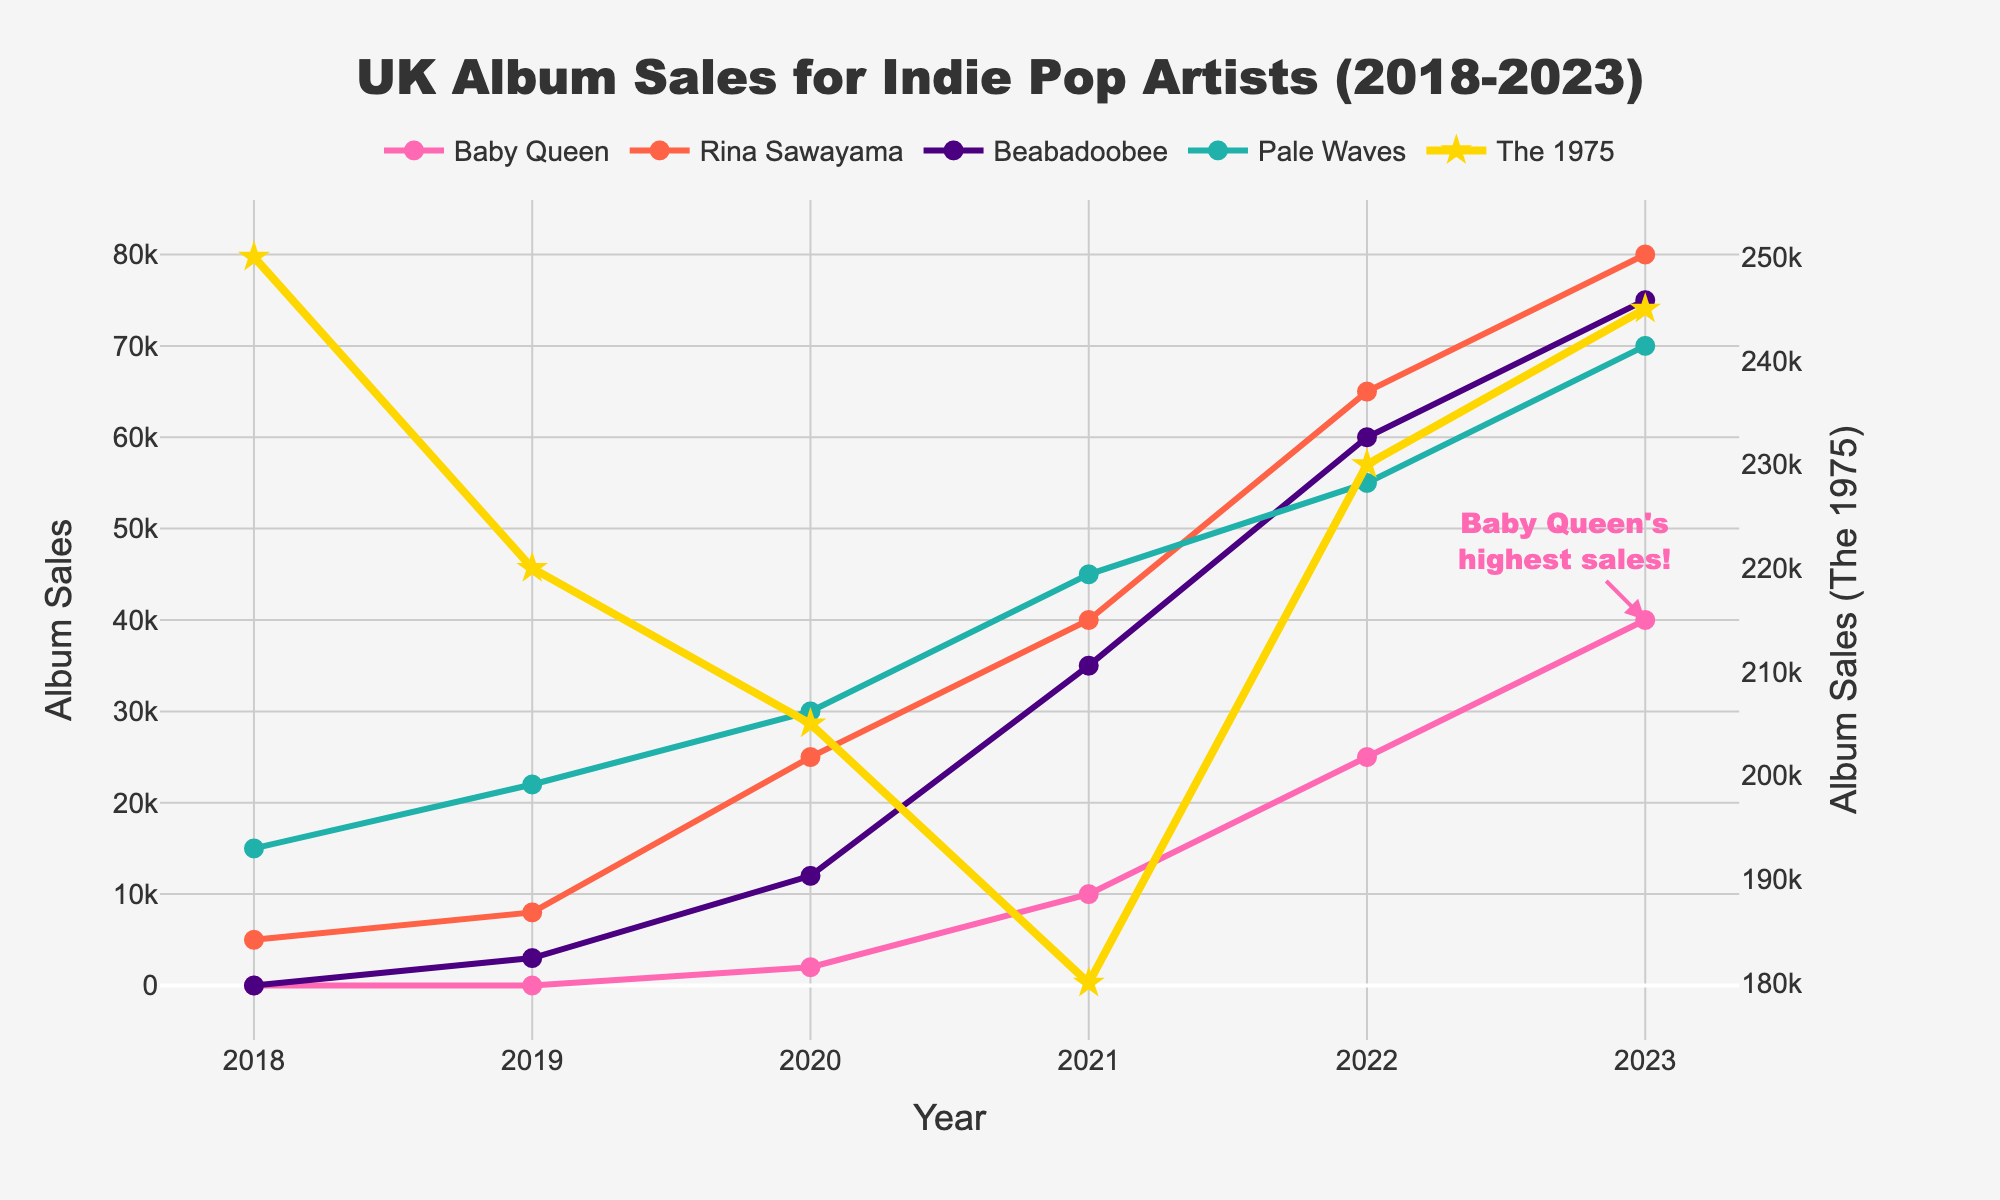What year did Baby Queen first appear in the album sales chart? Baby Queen first appears with sales greater than zero in the year 2020.
Answer: 2020 What is the difference in album sales between Rina Sawayama and Beabadoobee in 2021? In 2021, Rina Sawayama sold 40,000 albums, and Beabadoobee sold 35,000. The difference is 40,000 - 35,000 = 5,000.
Answer: 5,000 Which year saw the highest album sales for Baby Queen? By examining the trend of Baby Queen's sales, the highest value occurs in 2023.
Answer: 2023 How do the album sales of Pale Waves compare between 2018 and 2023? Pale Waves sold 15,000 albums in 2018 and 70,000 albums in 2023. This shows an increase of 70,000 - 15,000 = 55,000.
Answer: Increased by 55,000 What colors are used to represent Baby Queen and Beabadoobee in the plot? The figure represents Baby Queen with a pink line and Beabadoobee with an indigo line.
Answer: Pink and Indigo What is the total album sales for The 1975 over the 6-year period? The album sales are 250,000 (2018) + 220,000 (2019) + 205,000 (2020) + 180,000 (2021) + 230,000 (2022) + 245,000 (2023) = 1,330,000.
Answer: 1,330,000 Which year showed the largest increase in sales for Rina Sawayama compared to the previous year? Rina Sawayama's sales saw the largest increase from 2019 to 2020, going from 8,000 to 25,000, which is an increase of 17,000.
Answer: 2020 What is the average album sales in 2020 for Baby Queen, Rina Sawayama, and Beabadoobee? The sales in 2020 are 2,000 (Baby Queen), 25,000 (Rina Sawayama), and 12,000 (Beabadoobee). The average is (2,000 + 25,000 + 12,000) / 3 = 13,000.
Answer: 13,000 Which artist had the highest album sales in 2022? In 2022, The 1975 had the highest album sales of 230,000.
Answer: The 1975 What visual symbol is used to represent The 1975’s data points in the plot? The 1975’s data points are represented by star-shaped markers.
Answer: Star-shaped markers 